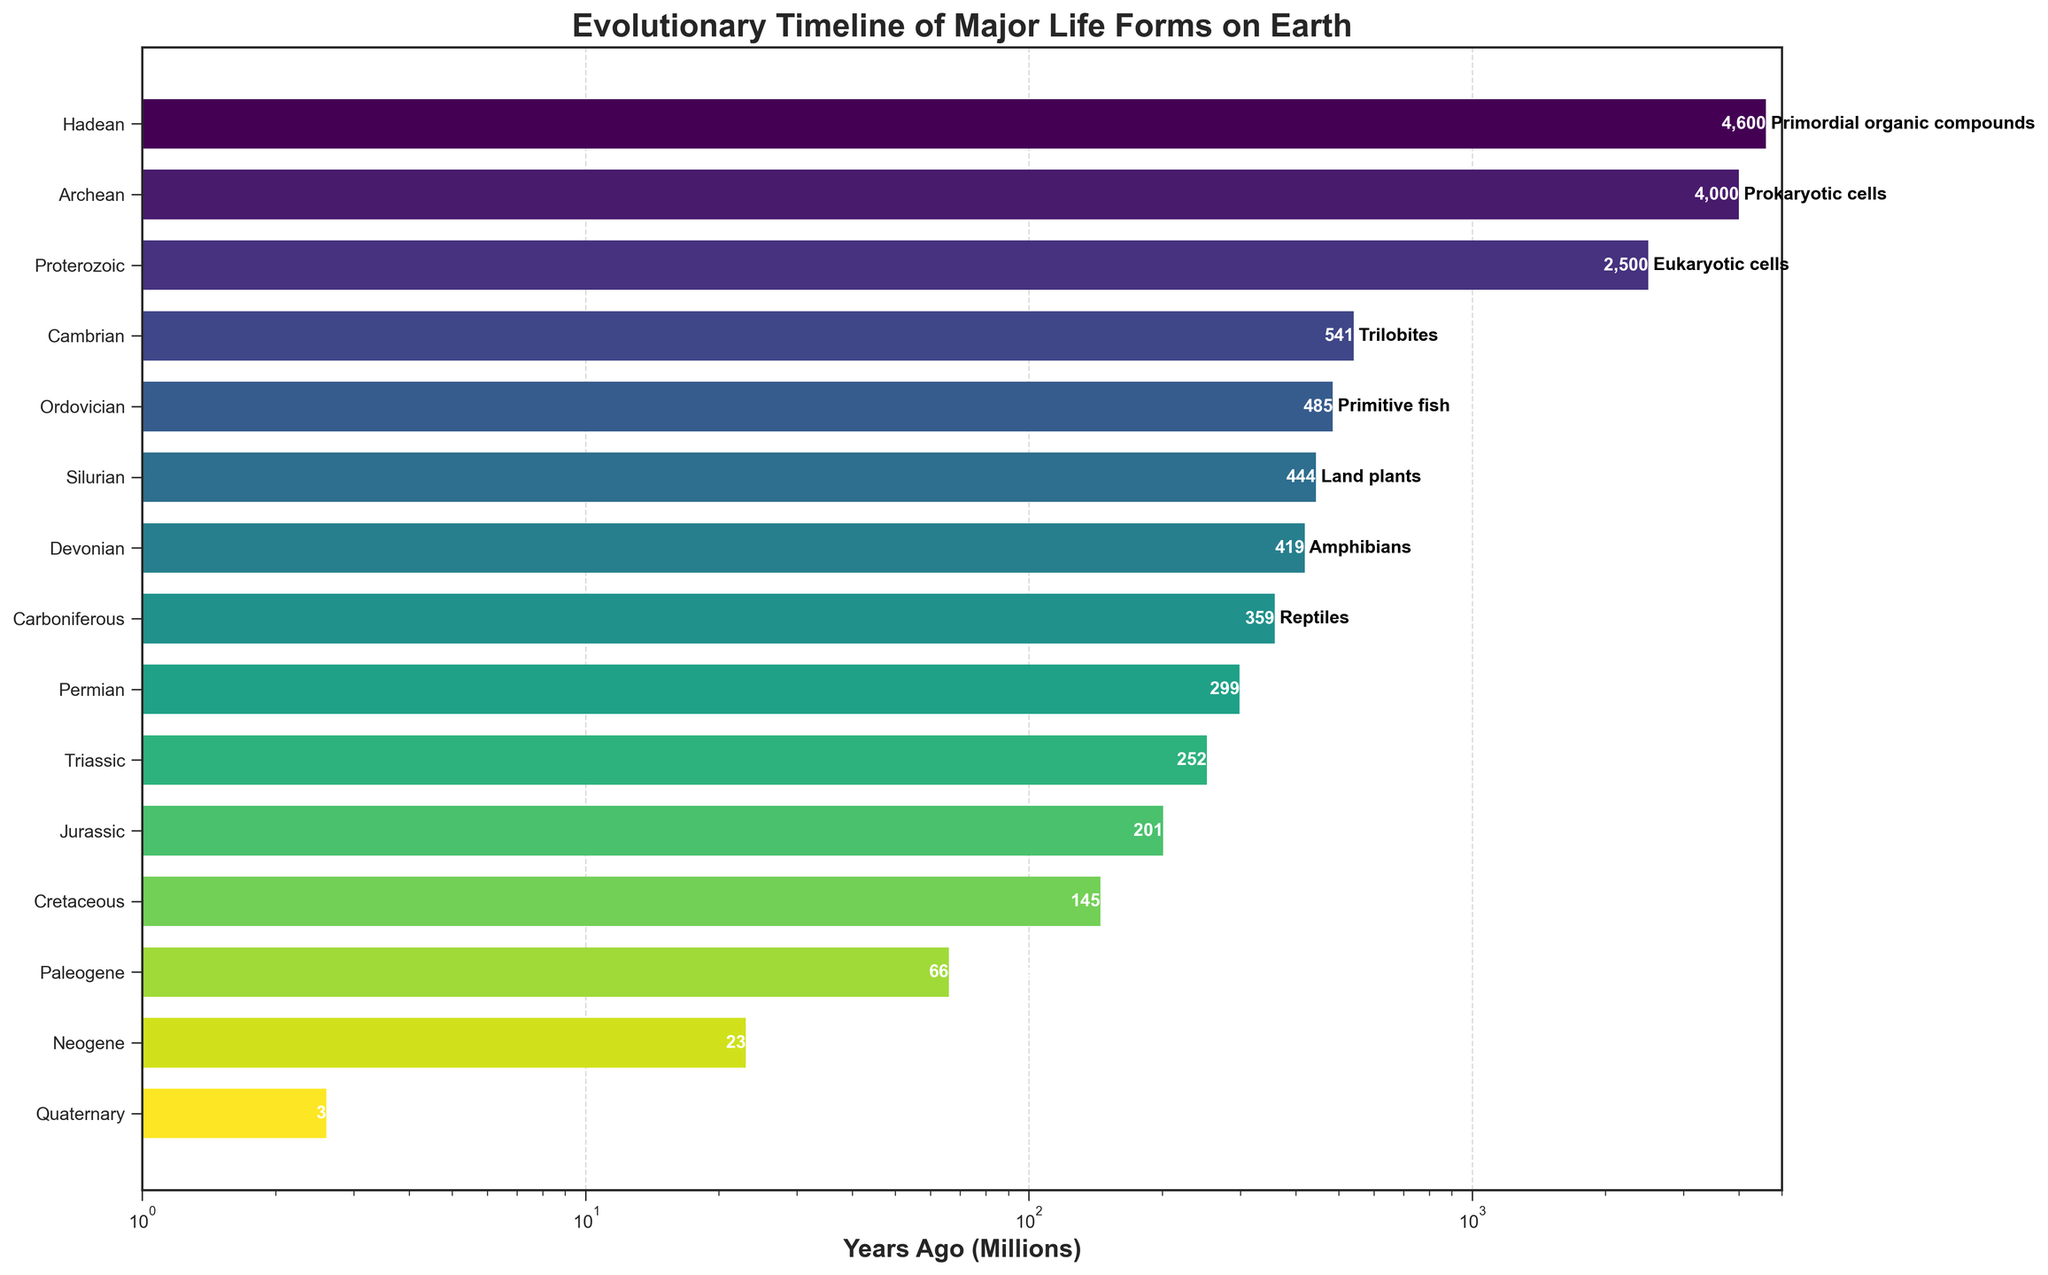What is the oldest geological era shown on the chart and what major life forms are associated with it? The chart shows the eras in chronological order from bottom to top. The oldest geological era depicted is the Hadean era, which is represented at the top of the chart. The major life forms associated with the Hadean era are primordial organic compounds.
Answer: Hadean, primordial organic compounds Which era marks the appearance of amphibians, and approximately how many millions of years ago did it occur? By examining the labels on the bars, we can identify that amphibians appeared in the Devonian era. The bar associated with the Devonian era shows that it occurred around 419 million years ago.
Answer: Devonian, approximately 419 million years ago During which era did eukaryotic cells first appear, and how many millions of years ago was it? To find the appearance of eukaryotic cells, we look at the Proterozoic era in the chart. The Proterozoic era is associated with eukaryotic cells, and the start of this era was about 2500 million years ago according to the chart.
Answer: Proterozoic, approximately 2500 million years ago Compare the eras when land plants and hominids first appeared. Which occurred earlier, and by approximately how much time? Land plants first appeared in the Silurian era (around 444 million years ago) while hominids appeared in the Neogene era (around 23 million years ago). The difference between these two occurrences is roughly 421 million years (444 - 23).
Answer: Silurian occurred earlier by approximately 421 million years What is the time range for the Cretaceous era, and which major life forms appeared during this period? The chart indicates that the Cretaceous era ranges from 145 million years ago to 66 million years ago. The major life forms that appeared during this era are flowering plants.
Answer: 145-66 million years ago, flowering plants Identify the geological era in which Homo sapiens appeared, and how does its time period compare in length to the Triassic era? Homo sapiens appeared in the Quaternary era. The Quaternary era spans from 2.6 million years ago to the present, while the Triassic era spans from 252 million years ago to 201 million years ago. The length of the Quaternary era is approximately 2.6 million years, which is significantly shorter than the Triassic era, which is about 51 million years long (252 - 201).
Answer: Quaternary, the Triassic era is about 48.4 million years longer What is the relationship between the occurrence of reptiles and birds in terms of their geological eras? Observing the chart, reptiles first appeared in the Carboniferous era (approximately 359 million years ago), while birds appeared later during the Jurassic era (about 201 million years ago). Therefore, reptiles occurred earlier than birds by roughly 158 million years (359 - 201).
Answer: Reptiles occurred earlier by approximately 158 million years Which era represents the emergence of dinosaurs, and what is the era immediately following it in the timeline? Dinosaurs appeared in the Triassic era as indicated by the chart. The era that immediately follows the Triassic era in the evolutionary timeline is the Jurassic era.
Answer: Triassic, Jurassic Based on the chart, what duration in millions of years does the Cambrian era cover, and what major life forms emerged during this time? The Cambrian era covers the time span from 541 million years ago to 485 million years ago, which is 56 million years. The major life forms that emerged during the Cambrian era are trilobites.
Answer: 56 million years, trilobites 